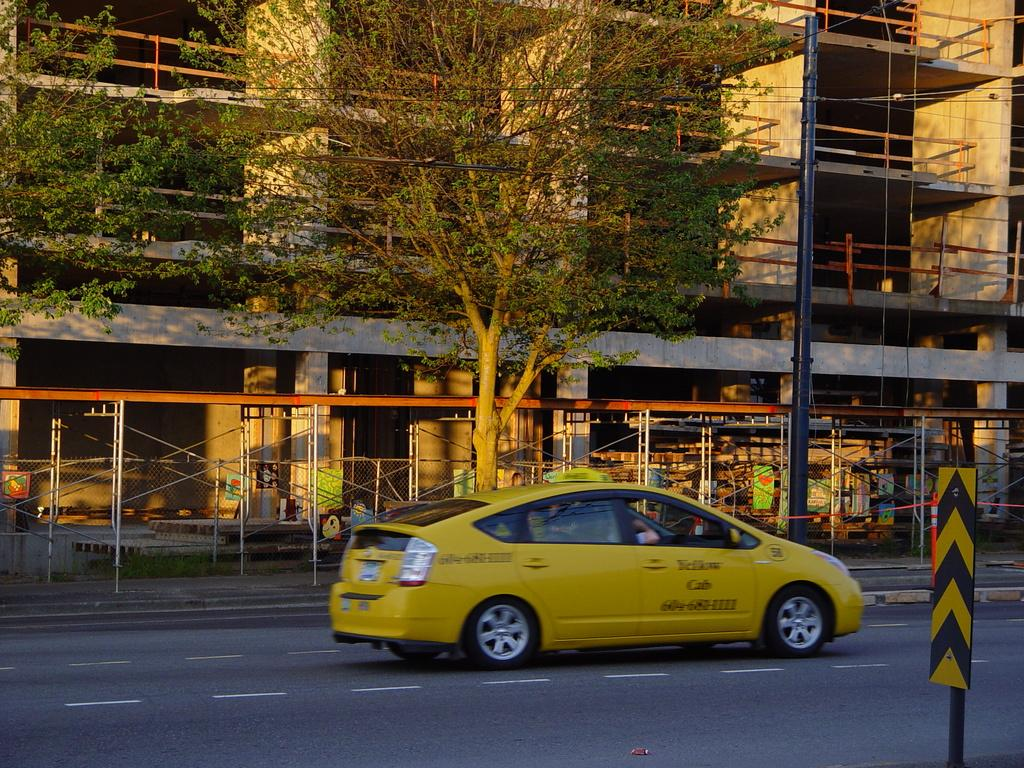<image>
Write a terse but informative summary of the picture. The phone number on the side of a yellow cab is 604-683-1111. 